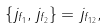Convert formula to latex. <formula><loc_0><loc_0><loc_500><loc_500>\{ j _ { { f } _ { 1 } } , j _ { { f } _ { 2 } } \} = j _ { { f } _ { 1 2 } } ,</formula> 